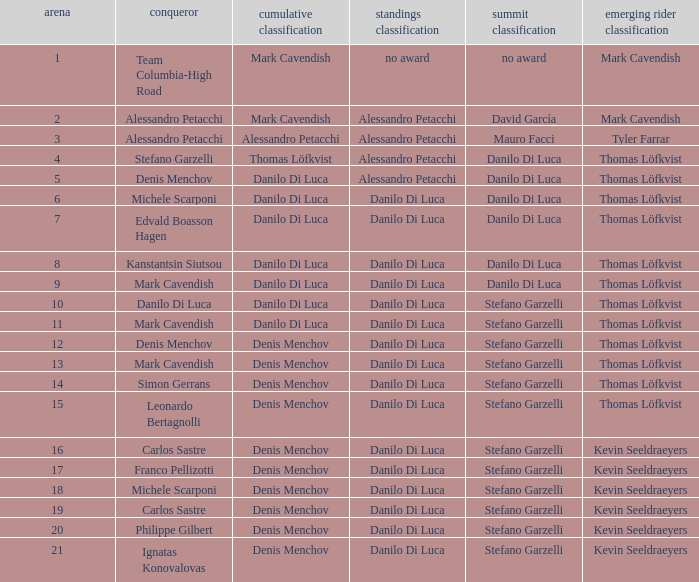When philippe gilbert is the winner who is the points classification? Danilo Di Luca. 